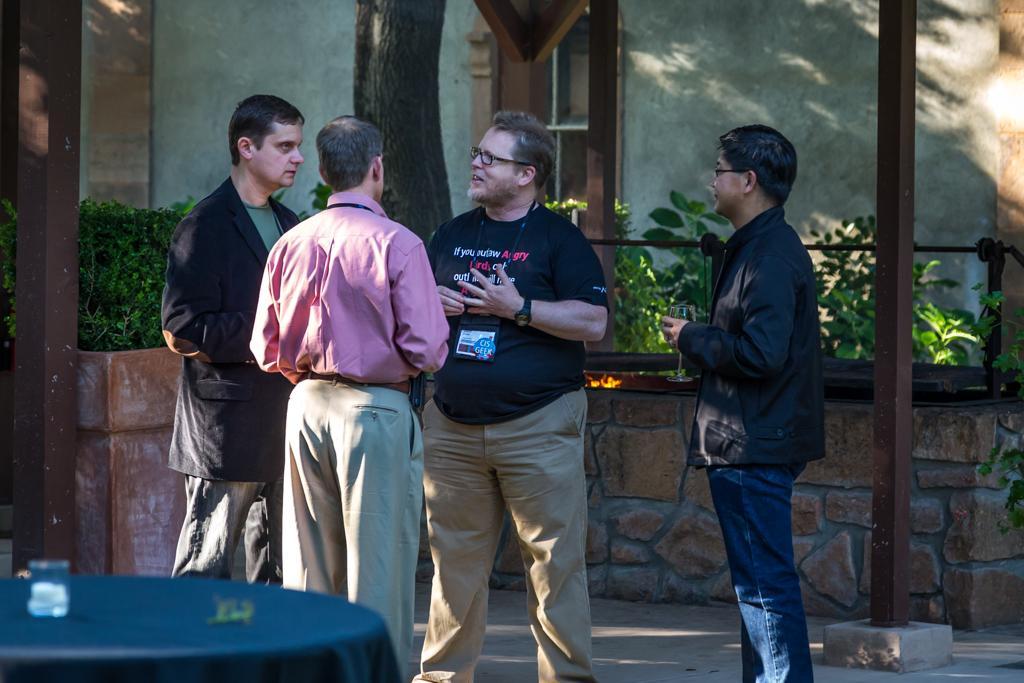Could you give a brief overview of what you see in this image? In this picture there are four people standing and discussing and in front of them there is a table on which there is some thing and behind them there are some plants. 